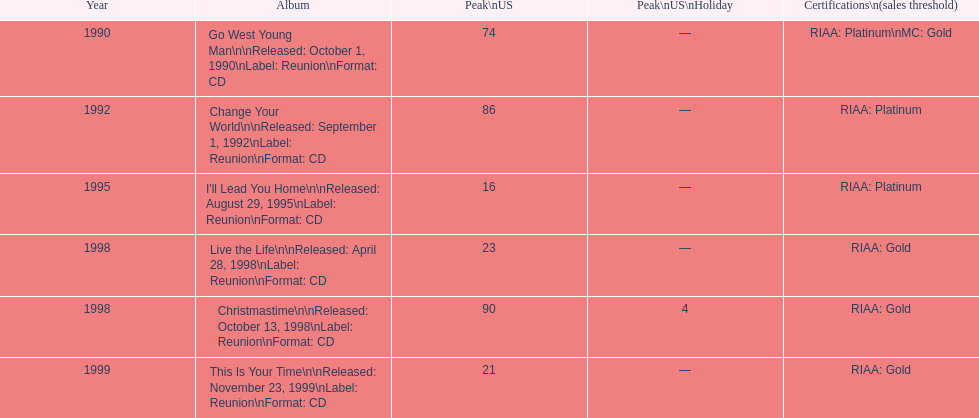What year comes after 1995? 1998. 